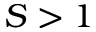Convert formula to latex. <formula><loc_0><loc_0><loc_500><loc_500>S > 1</formula> 